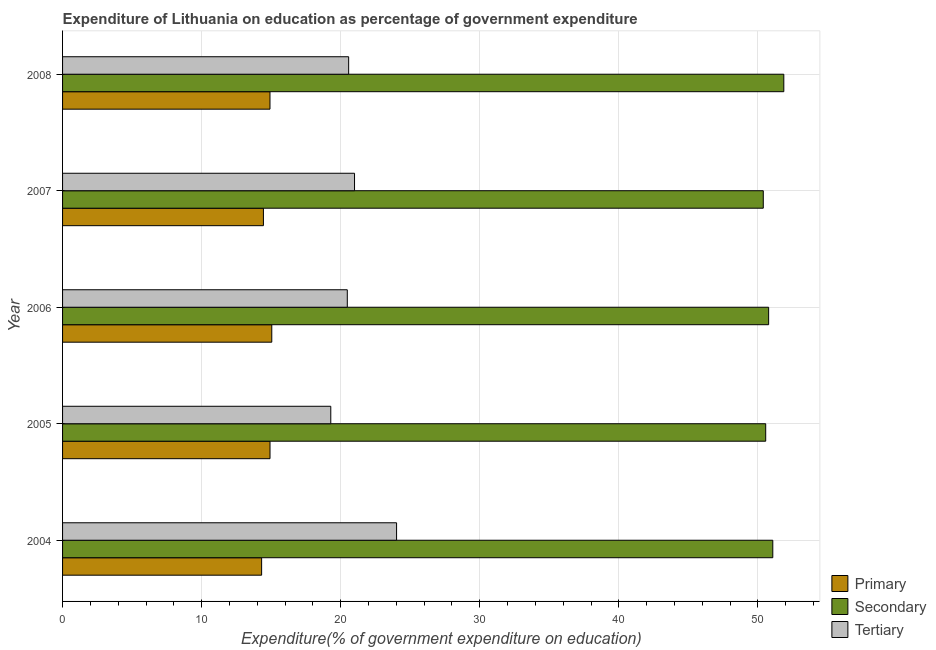How many different coloured bars are there?
Keep it short and to the point. 3. Are the number of bars per tick equal to the number of legend labels?
Keep it short and to the point. Yes. How many bars are there on the 2nd tick from the bottom?
Provide a succinct answer. 3. What is the expenditure on tertiary education in 2006?
Offer a terse response. 20.47. Across all years, what is the maximum expenditure on tertiary education?
Keep it short and to the point. 24.02. Across all years, what is the minimum expenditure on primary education?
Offer a very short reply. 14.31. In which year was the expenditure on tertiary education maximum?
Provide a short and direct response. 2004. What is the total expenditure on primary education in the graph?
Ensure brevity in your answer.  73.63. What is the difference between the expenditure on primary education in 2007 and that in 2008?
Keep it short and to the point. -0.47. What is the difference between the expenditure on tertiary education in 2008 and the expenditure on primary education in 2004?
Give a very brief answer. 6.26. What is the average expenditure on tertiary education per year?
Provide a succinct answer. 21.07. In the year 2004, what is the difference between the expenditure on secondary education and expenditure on tertiary education?
Offer a terse response. 27.05. What is the ratio of the expenditure on tertiary education in 2004 to that in 2005?
Provide a succinct answer. 1.25. Is the difference between the expenditure on primary education in 2005 and 2007 greater than the difference between the expenditure on tertiary education in 2005 and 2007?
Keep it short and to the point. Yes. What is the difference between the highest and the second highest expenditure on secondary education?
Offer a terse response. 0.79. What is the difference between the highest and the lowest expenditure on secondary education?
Keep it short and to the point. 1.48. What does the 3rd bar from the top in 2008 represents?
Offer a very short reply. Primary. What does the 1st bar from the bottom in 2004 represents?
Ensure brevity in your answer.  Primary. How many years are there in the graph?
Give a very brief answer. 5. What is the difference between two consecutive major ticks on the X-axis?
Your response must be concise. 10. Are the values on the major ticks of X-axis written in scientific E-notation?
Give a very brief answer. No. Does the graph contain grids?
Make the answer very short. Yes. What is the title of the graph?
Offer a very short reply. Expenditure of Lithuania on education as percentage of government expenditure. What is the label or title of the X-axis?
Offer a very short reply. Expenditure(% of government expenditure on education). What is the label or title of the Y-axis?
Ensure brevity in your answer.  Year. What is the Expenditure(% of government expenditure on education) in Primary in 2004?
Provide a short and direct response. 14.31. What is the Expenditure(% of government expenditure on education) of Secondary in 2004?
Give a very brief answer. 51.07. What is the Expenditure(% of government expenditure on education) in Tertiary in 2004?
Offer a terse response. 24.02. What is the Expenditure(% of government expenditure on education) of Primary in 2005?
Offer a very short reply. 14.92. What is the Expenditure(% of government expenditure on education) of Secondary in 2005?
Your answer should be very brief. 50.56. What is the Expenditure(% of government expenditure on education) in Tertiary in 2005?
Provide a succinct answer. 19.29. What is the Expenditure(% of government expenditure on education) in Primary in 2006?
Ensure brevity in your answer.  15.04. What is the Expenditure(% of government expenditure on education) of Secondary in 2006?
Give a very brief answer. 50.77. What is the Expenditure(% of government expenditure on education) in Tertiary in 2006?
Offer a terse response. 20.47. What is the Expenditure(% of government expenditure on education) of Primary in 2007?
Your answer should be very brief. 14.44. What is the Expenditure(% of government expenditure on education) in Secondary in 2007?
Give a very brief answer. 50.39. What is the Expenditure(% of government expenditure on education) of Tertiary in 2007?
Ensure brevity in your answer.  20.99. What is the Expenditure(% of government expenditure on education) of Primary in 2008?
Your answer should be compact. 14.92. What is the Expenditure(% of government expenditure on education) in Secondary in 2008?
Your response must be concise. 51.86. What is the Expenditure(% of government expenditure on education) of Tertiary in 2008?
Your answer should be very brief. 20.57. Across all years, what is the maximum Expenditure(% of government expenditure on education) of Primary?
Offer a terse response. 15.04. Across all years, what is the maximum Expenditure(% of government expenditure on education) of Secondary?
Your response must be concise. 51.86. Across all years, what is the maximum Expenditure(% of government expenditure on education) in Tertiary?
Provide a short and direct response. 24.02. Across all years, what is the minimum Expenditure(% of government expenditure on education) in Primary?
Ensure brevity in your answer.  14.31. Across all years, what is the minimum Expenditure(% of government expenditure on education) of Secondary?
Your response must be concise. 50.39. Across all years, what is the minimum Expenditure(% of government expenditure on education) in Tertiary?
Keep it short and to the point. 19.29. What is the total Expenditure(% of government expenditure on education) of Primary in the graph?
Offer a very short reply. 73.63. What is the total Expenditure(% of government expenditure on education) in Secondary in the graph?
Ensure brevity in your answer.  254.65. What is the total Expenditure(% of government expenditure on education) in Tertiary in the graph?
Make the answer very short. 105.35. What is the difference between the Expenditure(% of government expenditure on education) of Primary in 2004 and that in 2005?
Your answer should be very brief. -0.6. What is the difference between the Expenditure(% of government expenditure on education) in Secondary in 2004 and that in 2005?
Ensure brevity in your answer.  0.51. What is the difference between the Expenditure(% of government expenditure on education) in Tertiary in 2004 and that in 2005?
Offer a terse response. 4.73. What is the difference between the Expenditure(% of government expenditure on education) of Primary in 2004 and that in 2006?
Your response must be concise. -0.73. What is the difference between the Expenditure(% of government expenditure on education) in Secondary in 2004 and that in 2006?
Give a very brief answer. 0.3. What is the difference between the Expenditure(% of government expenditure on education) in Tertiary in 2004 and that in 2006?
Your answer should be very brief. 3.54. What is the difference between the Expenditure(% of government expenditure on education) in Primary in 2004 and that in 2007?
Offer a terse response. -0.13. What is the difference between the Expenditure(% of government expenditure on education) of Secondary in 2004 and that in 2007?
Offer a terse response. 0.68. What is the difference between the Expenditure(% of government expenditure on education) of Tertiary in 2004 and that in 2007?
Your response must be concise. 3.02. What is the difference between the Expenditure(% of government expenditure on education) in Primary in 2004 and that in 2008?
Ensure brevity in your answer.  -0.6. What is the difference between the Expenditure(% of government expenditure on education) of Secondary in 2004 and that in 2008?
Offer a very short reply. -0.79. What is the difference between the Expenditure(% of government expenditure on education) in Tertiary in 2004 and that in 2008?
Make the answer very short. 3.45. What is the difference between the Expenditure(% of government expenditure on education) in Primary in 2005 and that in 2006?
Keep it short and to the point. -0.13. What is the difference between the Expenditure(% of government expenditure on education) in Secondary in 2005 and that in 2006?
Offer a terse response. -0.21. What is the difference between the Expenditure(% of government expenditure on education) of Tertiary in 2005 and that in 2006?
Give a very brief answer. -1.19. What is the difference between the Expenditure(% of government expenditure on education) in Primary in 2005 and that in 2007?
Provide a short and direct response. 0.47. What is the difference between the Expenditure(% of government expenditure on education) in Secondary in 2005 and that in 2007?
Provide a succinct answer. 0.17. What is the difference between the Expenditure(% of government expenditure on education) in Tertiary in 2005 and that in 2007?
Provide a succinct answer. -1.71. What is the difference between the Expenditure(% of government expenditure on education) in Primary in 2005 and that in 2008?
Keep it short and to the point. 0. What is the difference between the Expenditure(% of government expenditure on education) in Secondary in 2005 and that in 2008?
Offer a very short reply. -1.3. What is the difference between the Expenditure(% of government expenditure on education) in Tertiary in 2005 and that in 2008?
Provide a short and direct response. -1.29. What is the difference between the Expenditure(% of government expenditure on education) of Primary in 2006 and that in 2007?
Make the answer very short. 0.6. What is the difference between the Expenditure(% of government expenditure on education) in Secondary in 2006 and that in 2007?
Your answer should be very brief. 0.39. What is the difference between the Expenditure(% of government expenditure on education) of Tertiary in 2006 and that in 2007?
Your response must be concise. -0.52. What is the difference between the Expenditure(% of government expenditure on education) in Primary in 2006 and that in 2008?
Provide a succinct answer. 0.13. What is the difference between the Expenditure(% of government expenditure on education) in Secondary in 2006 and that in 2008?
Give a very brief answer. -1.09. What is the difference between the Expenditure(% of government expenditure on education) in Tertiary in 2006 and that in 2008?
Your answer should be compact. -0.1. What is the difference between the Expenditure(% of government expenditure on education) of Primary in 2007 and that in 2008?
Make the answer very short. -0.47. What is the difference between the Expenditure(% of government expenditure on education) in Secondary in 2007 and that in 2008?
Your answer should be very brief. -1.48. What is the difference between the Expenditure(% of government expenditure on education) of Tertiary in 2007 and that in 2008?
Provide a short and direct response. 0.42. What is the difference between the Expenditure(% of government expenditure on education) of Primary in 2004 and the Expenditure(% of government expenditure on education) of Secondary in 2005?
Provide a short and direct response. -36.25. What is the difference between the Expenditure(% of government expenditure on education) of Primary in 2004 and the Expenditure(% of government expenditure on education) of Tertiary in 2005?
Provide a succinct answer. -4.97. What is the difference between the Expenditure(% of government expenditure on education) of Secondary in 2004 and the Expenditure(% of government expenditure on education) of Tertiary in 2005?
Offer a very short reply. 31.78. What is the difference between the Expenditure(% of government expenditure on education) of Primary in 2004 and the Expenditure(% of government expenditure on education) of Secondary in 2006?
Keep it short and to the point. -36.46. What is the difference between the Expenditure(% of government expenditure on education) in Primary in 2004 and the Expenditure(% of government expenditure on education) in Tertiary in 2006?
Your answer should be very brief. -6.16. What is the difference between the Expenditure(% of government expenditure on education) in Secondary in 2004 and the Expenditure(% of government expenditure on education) in Tertiary in 2006?
Give a very brief answer. 30.6. What is the difference between the Expenditure(% of government expenditure on education) of Primary in 2004 and the Expenditure(% of government expenditure on education) of Secondary in 2007?
Provide a succinct answer. -36.07. What is the difference between the Expenditure(% of government expenditure on education) of Primary in 2004 and the Expenditure(% of government expenditure on education) of Tertiary in 2007?
Ensure brevity in your answer.  -6.68. What is the difference between the Expenditure(% of government expenditure on education) in Secondary in 2004 and the Expenditure(% of government expenditure on education) in Tertiary in 2007?
Make the answer very short. 30.08. What is the difference between the Expenditure(% of government expenditure on education) of Primary in 2004 and the Expenditure(% of government expenditure on education) of Secondary in 2008?
Your answer should be very brief. -37.55. What is the difference between the Expenditure(% of government expenditure on education) in Primary in 2004 and the Expenditure(% of government expenditure on education) in Tertiary in 2008?
Make the answer very short. -6.26. What is the difference between the Expenditure(% of government expenditure on education) of Secondary in 2004 and the Expenditure(% of government expenditure on education) of Tertiary in 2008?
Make the answer very short. 30.5. What is the difference between the Expenditure(% of government expenditure on education) of Primary in 2005 and the Expenditure(% of government expenditure on education) of Secondary in 2006?
Make the answer very short. -35.86. What is the difference between the Expenditure(% of government expenditure on education) of Primary in 2005 and the Expenditure(% of government expenditure on education) of Tertiary in 2006?
Make the answer very short. -5.56. What is the difference between the Expenditure(% of government expenditure on education) in Secondary in 2005 and the Expenditure(% of government expenditure on education) in Tertiary in 2006?
Ensure brevity in your answer.  30.09. What is the difference between the Expenditure(% of government expenditure on education) of Primary in 2005 and the Expenditure(% of government expenditure on education) of Secondary in 2007?
Offer a very short reply. -35.47. What is the difference between the Expenditure(% of government expenditure on education) of Primary in 2005 and the Expenditure(% of government expenditure on education) of Tertiary in 2007?
Provide a succinct answer. -6.08. What is the difference between the Expenditure(% of government expenditure on education) in Secondary in 2005 and the Expenditure(% of government expenditure on education) in Tertiary in 2007?
Provide a succinct answer. 29.57. What is the difference between the Expenditure(% of government expenditure on education) in Primary in 2005 and the Expenditure(% of government expenditure on education) in Secondary in 2008?
Keep it short and to the point. -36.95. What is the difference between the Expenditure(% of government expenditure on education) in Primary in 2005 and the Expenditure(% of government expenditure on education) in Tertiary in 2008?
Offer a terse response. -5.66. What is the difference between the Expenditure(% of government expenditure on education) in Secondary in 2005 and the Expenditure(% of government expenditure on education) in Tertiary in 2008?
Ensure brevity in your answer.  29.99. What is the difference between the Expenditure(% of government expenditure on education) in Primary in 2006 and the Expenditure(% of government expenditure on education) in Secondary in 2007?
Provide a short and direct response. -35.34. What is the difference between the Expenditure(% of government expenditure on education) of Primary in 2006 and the Expenditure(% of government expenditure on education) of Tertiary in 2007?
Your answer should be compact. -5.95. What is the difference between the Expenditure(% of government expenditure on education) of Secondary in 2006 and the Expenditure(% of government expenditure on education) of Tertiary in 2007?
Provide a short and direct response. 29.78. What is the difference between the Expenditure(% of government expenditure on education) in Primary in 2006 and the Expenditure(% of government expenditure on education) in Secondary in 2008?
Keep it short and to the point. -36.82. What is the difference between the Expenditure(% of government expenditure on education) in Primary in 2006 and the Expenditure(% of government expenditure on education) in Tertiary in 2008?
Give a very brief answer. -5.53. What is the difference between the Expenditure(% of government expenditure on education) of Secondary in 2006 and the Expenditure(% of government expenditure on education) of Tertiary in 2008?
Make the answer very short. 30.2. What is the difference between the Expenditure(% of government expenditure on education) in Primary in 2007 and the Expenditure(% of government expenditure on education) in Secondary in 2008?
Your answer should be very brief. -37.42. What is the difference between the Expenditure(% of government expenditure on education) of Primary in 2007 and the Expenditure(% of government expenditure on education) of Tertiary in 2008?
Your response must be concise. -6.13. What is the difference between the Expenditure(% of government expenditure on education) of Secondary in 2007 and the Expenditure(% of government expenditure on education) of Tertiary in 2008?
Provide a short and direct response. 29.81. What is the average Expenditure(% of government expenditure on education) of Primary per year?
Give a very brief answer. 14.73. What is the average Expenditure(% of government expenditure on education) of Secondary per year?
Offer a terse response. 50.93. What is the average Expenditure(% of government expenditure on education) of Tertiary per year?
Offer a very short reply. 21.07. In the year 2004, what is the difference between the Expenditure(% of government expenditure on education) of Primary and Expenditure(% of government expenditure on education) of Secondary?
Offer a very short reply. -36.76. In the year 2004, what is the difference between the Expenditure(% of government expenditure on education) in Primary and Expenditure(% of government expenditure on education) in Tertiary?
Provide a short and direct response. -9.7. In the year 2004, what is the difference between the Expenditure(% of government expenditure on education) in Secondary and Expenditure(% of government expenditure on education) in Tertiary?
Make the answer very short. 27.05. In the year 2005, what is the difference between the Expenditure(% of government expenditure on education) of Primary and Expenditure(% of government expenditure on education) of Secondary?
Offer a very short reply. -35.64. In the year 2005, what is the difference between the Expenditure(% of government expenditure on education) in Primary and Expenditure(% of government expenditure on education) in Tertiary?
Ensure brevity in your answer.  -4.37. In the year 2005, what is the difference between the Expenditure(% of government expenditure on education) in Secondary and Expenditure(% of government expenditure on education) in Tertiary?
Your response must be concise. 31.27. In the year 2006, what is the difference between the Expenditure(% of government expenditure on education) of Primary and Expenditure(% of government expenditure on education) of Secondary?
Ensure brevity in your answer.  -35.73. In the year 2006, what is the difference between the Expenditure(% of government expenditure on education) in Primary and Expenditure(% of government expenditure on education) in Tertiary?
Your answer should be compact. -5.43. In the year 2006, what is the difference between the Expenditure(% of government expenditure on education) in Secondary and Expenditure(% of government expenditure on education) in Tertiary?
Give a very brief answer. 30.3. In the year 2007, what is the difference between the Expenditure(% of government expenditure on education) of Primary and Expenditure(% of government expenditure on education) of Secondary?
Your answer should be compact. -35.94. In the year 2007, what is the difference between the Expenditure(% of government expenditure on education) of Primary and Expenditure(% of government expenditure on education) of Tertiary?
Provide a succinct answer. -6.55. In the year 2007, what is the difference between the Expenditure(% of government expenditure on education) in Secondary and Expenditure(% of government expenditure on education) in Tertiary?
Your answer should be compact. 29.39. In the year 2008, what is the difference between the Expenditure(% of government expenditure on education) in Primary and Expenditure(% of government expenditure on education) in Secondary?
Keep it short and to the point. -36.95. In the year 2008, what is the difference between the Expenditure(% of government expenditure on education) of Primary and Expenditure(% of government expenditure on education) of Tertiary?
Provide a short and direct response. -5.66. In the year 2008, what is the difference between the Expenditure(% of government expenditure on education) in Secondary and Expenditure(% of government expenditure on education) in Tertiary?
Provide a succinct answer. 31.29. What is the ratio of the Expenditure(% of government expenditure on education) of Primary in 2004 to that in 2005?
Offer a terse response. 0.96. What is the ratio of the Expenditure(% of government expenditure on education) of Tertiary in 2004 to that in 2005?
Your answer should be very brief. 1.25. What is the ratio of the Expenditure(% of government expenditure on education) of Primary in 2004 to that in 2006?
Provide a succinct answer. 0.95. What is the ratio of the Expenditure(% of government expenditure on education) in Secondary in 2004 to that in 2006?
Offer a terse response. 1.01. What is the ratio of the Expenditure(% of government expenditure on education) in Tertiary in 2004 to that in 2006?
Your answer should be very brief. 1.17. What is the ratio of the Expenditure(% of government expenditure on education) in Primary in 2004 to that in 2007?
Offer a terse response. 0.99. What is the ratio of the Expenditure(% of government expenditure on education) of Secondary in 2004 to that in 2007?
Ensure brevity in your answer.  1.01. What is the ratio of the Expenditure(% of government expenditure on education) in Tertiary in 2004 to that in 2007?
Offer a terse response. 1.14. What is the ratio of the Expenditure(% of government expenditure on education) in Primary in 2004 to that in 2008?
Your response must be concise. 0.96. What is the ratio of the Expenditure(% of government expenditure on education) of Secondary in 2004 to that in 2008?
Give a very brief answer. 0.98. What is the ratio of the Expenditure(% of government expenditure on education) in Tertiary in 2004 to that in 2008?
Ensure brevity in your answer.  1.17. What is the ratio of the Expenditure(% of government expenditure on education) in Primary in 2005 to that in 2006?
Offer a very short reply. 0.99. What is the ratio of the Expenditure(% of government expenditure on education) in Secondary in 2005 to that in 2006?
Offer a terse response. 1. What is the ratio of the Expenditure(% of government expenditure on education) in Tertiary in 2005 to that in 2006?
Keep it short and to the point. 0.94. What is the ratio of the Expenditure(% of government expenditure on education) of Primary in 2005 to that in 2007?
Your answer should be very brief. 1.03. What is the ratio of the Expenditure(% of government expenditure on education) in Tertiary in 2005 to that in 2007?
Make the answer very short. 0.92. What is the ratio of the Expenditure(% of government expenditure on education) of Primary in 2005 to that in 2008?
Make the answer very short. 1. What is the ratio of the Expenditure(% of government expenditure on education) of Secondary in 2005 to that in 2008?
Give a very brief answer. 0.97. What is the ratio of the Expenditure(% of government expenditure on education) in Tertiary in 2005 to that in 2008?
Offer a very short reply. 0.94. What is the ratio of the Expenditure(% of government expenditure on education) in Primary in 2006 to that in 2007?
Provide a succinct answer. 1.04. What is the ratio of the Expenditure(% of government expenditure on education) of Secondary in 2006 to that in 2007?
Your response must be concise. 1.01. What is the ratio of the Expenditure(% of government expenditure on education) in Tertiary in 2006 to that in 2007?
Your answer should be very brief. 0.98. What is the ratio of the Expenditure(% of government expenditure on education) of Primary in 2006 to that in 2008?
Give a very brief answer. 1.01. What is the ratio of the Expenditure(% of government expenditure on education) in Secondary in 2006 to that in 2008?
Your response must be concise. 0.98. What is the ratio of the Expenditure(% of government expenditure on education) of Tertiary in 2006 to that in 2008?
Your answer should be compact. 1. What is the ratio of the Expenditure(% of government expenditure on education) of Primary in 2007 to that in 2008?
Your response must be concise. 0.97. What is the ratio of the Expenditure(% of government expenditure on education) of Secondary in 2007 to that in 2008?
Ensure brevity in your answer.  0.97. What is the ratio of the Expenditure(% of government expenditure on education) in Tertiary in 2007 to that in 2008?
Make the answer very short. 1.02. What is the difference between the highest and the second highest Expenditure(% of government expenditure on education) of Primary?
Give a very brief answer. 0.13. What is the difference between the highest and the second highest Expenditure(% of government expenditure on education) of Secondary?
Your answer should be very brief. 0.79. What is the difference between the highest and the second highest Expenditure(% of government expenditure on education) of Tertiary?
Your response must be concise. 3.02. What is the difference between the highest and the lowest Expenditure(% of government expenditure on education) in Primary?
Offer a terse response. 0.73. What is the difference between the highest and the lowest Expenditure(% of government expenditure on education) of Secondary?
Make the answer very short. 1.48. What is the difference between the highest and the lowest Expenditure(% of government expenditure on education) of Tertiary?
Your response must be concise. 4.73. 